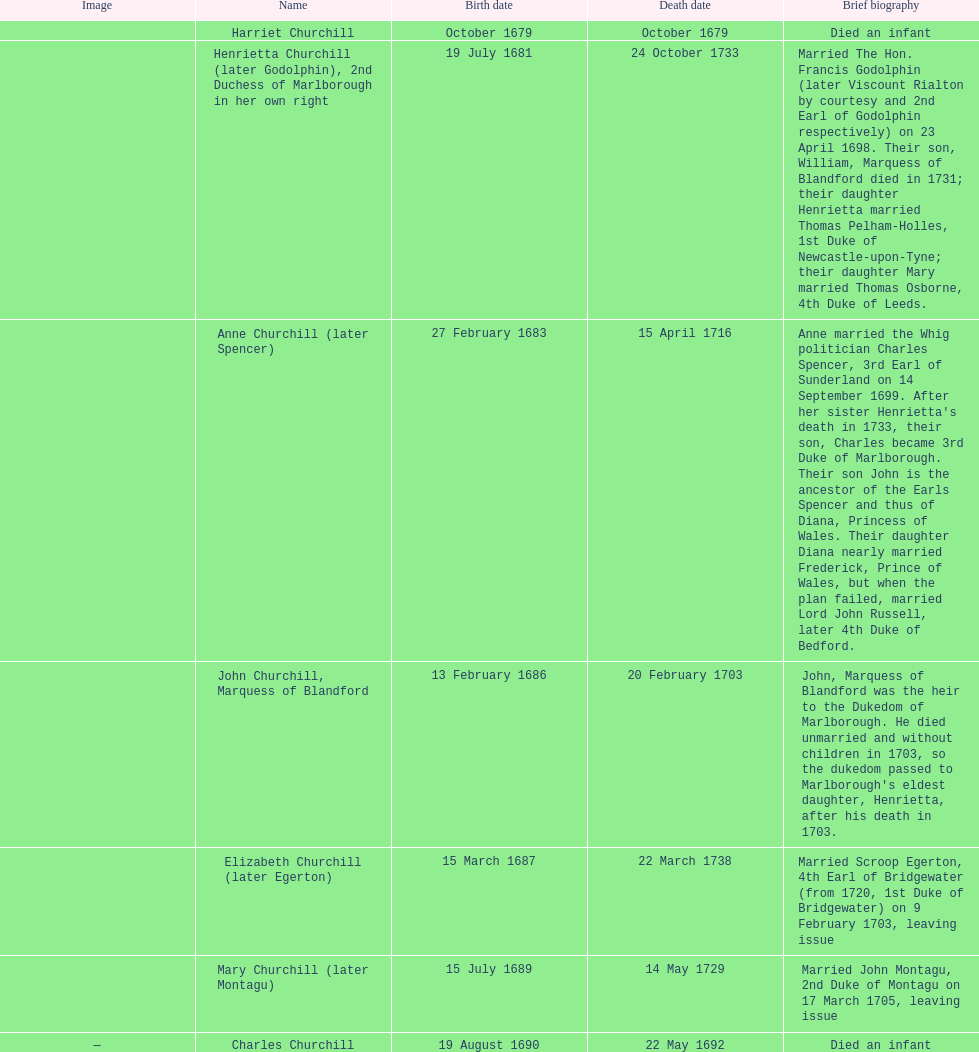What was the duration of anne churchill/spencer's life? 33. 